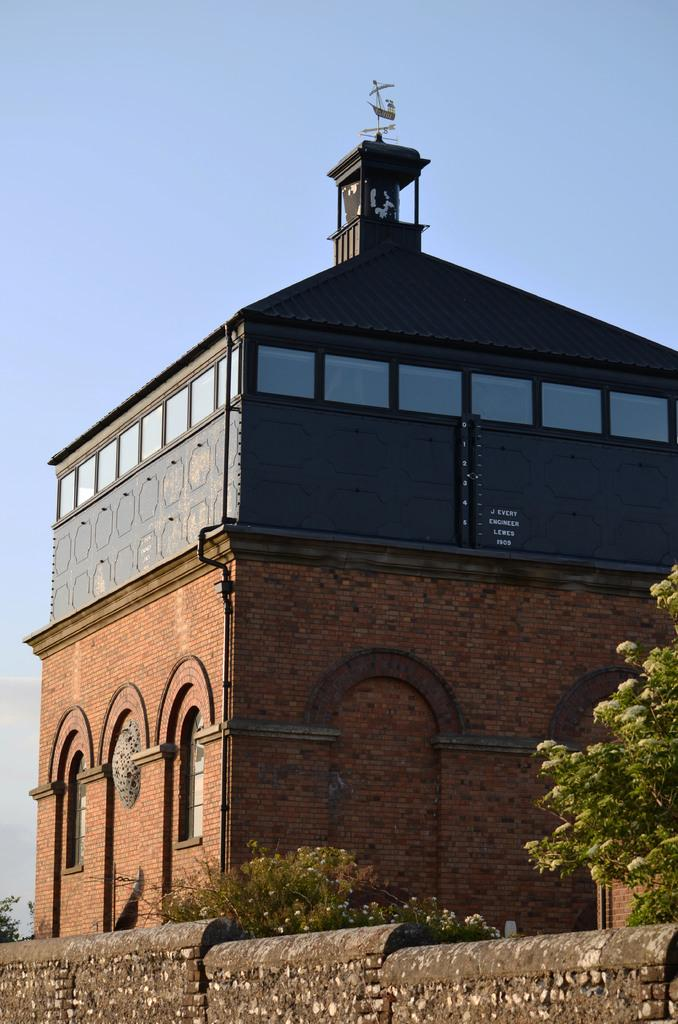What type of living organisms can be seen in the image? Plants can be seen in the image. What type of structure is present in the image? There is a building in the image. What is located beside the building? There is a wall beside the building. What can be seen in the background of the image? The sky is visible in the background of the image. What type of appliance can be seen in the image? There is no appliance present in the image. Are there any caves visible in the image? There are no caves visible in the image. 